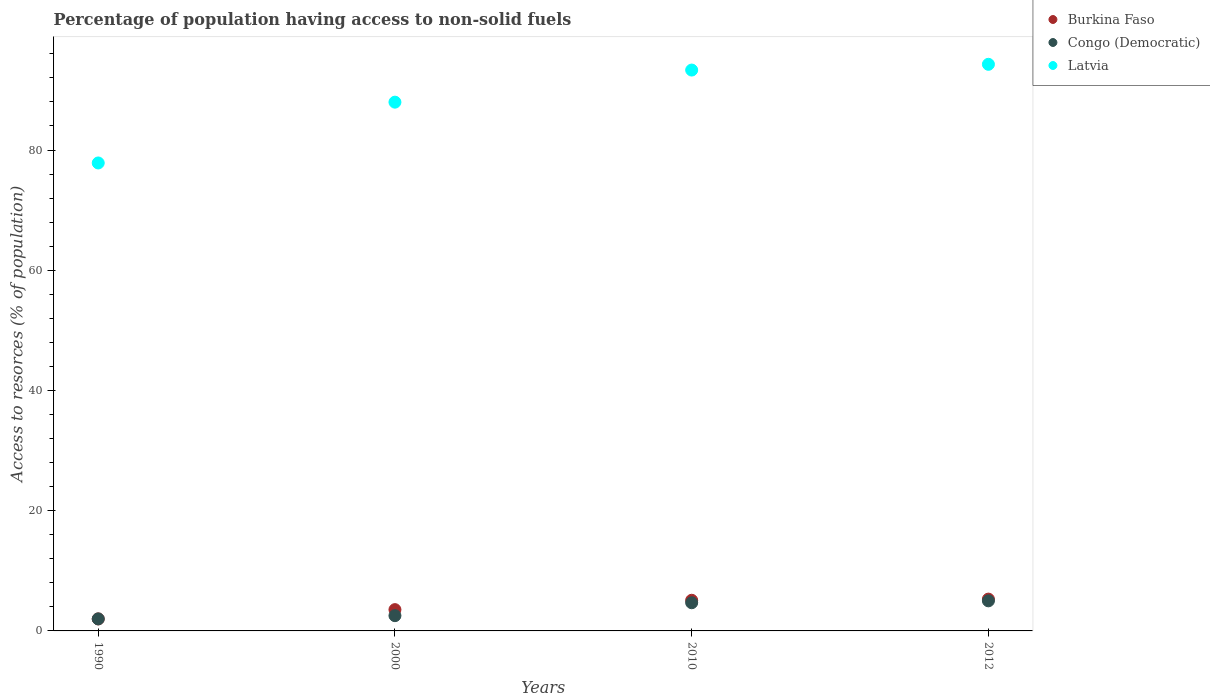How many different coloured dotlines are there?
Give a very brief answer. 3. Is the number of dotlines equal to the number of legend labels?
Offer a very short reply. Yes. What is the percentage of population having access to non-solid fuels in Latvia in 2012?
Keep it short and to the point. 94.26. Across all years, what is the maximum percentage of population having access to non-solid fuels in Burkina Faso?
Provide a succinct answer. 5.29. Across all years, what is the minimum percentage of population having access to non-solid fuels in Latvia?
Provide a short and direct response. 77.85. In which year was the percentage of population having access to non-solid fuels in Burkina Faso maximum?
Offer a terse response. 2012. What is the total percentage of population having access to non-solid fuels in Burkina Faso in the graph?
Offer a very short reply. 15.93. What is the difference between the percentage of population having access to non-solid fuels in Congo (Democratic) in 1990 and that in 2000?
Make the answer very short. -0.54. What is the difference between the percentage of population having access to non-solid fuels in Latvia in 1990 and the percentage of population having access to non-solid fuels in Congo (Democratic) in 2012?
Offer a very short reply. 72.85. What is the average percentage of population having access to non-solid fuels in Burkina Faso per year?
Ensure brevity in your answer.  3.98. In the year 2012, what is the difference between the percentage of population having access to non-solid fuels in Congo (Democratic) and percentage of population having access to non-solid fuels in Burkina Faso?
Your response must be concise. -0.29. In how many years, is the percentage of population having access to non-solid fuels in Latvia greater than 84 %?
Ensure brevity in your answer.  3. What is the ratio of the percentage of population having access to non-solid fuels in Congo (Democratic) in 1990 to that in 2012?
Provide a short and direct response. 0.4. Is the percentage of population having access to non-solid fuels in Burkina Faso in 1990 less than that in 2000?
Give a very brief answer. Yes. Is the difference between the percentage of population having access to non-solid fuels in Congo (Democratic) in 1990 and 2010 greater than the difference between the percentage of population having access to non-solid fuels in Burkina Faso in 1990 and 2010?
Make the answer very short. Yes. What is the difference between the highest and the second highest percentage of population having access to non-solid fuels in Latvia?
Give a very brief answer. 0.96. What is the difference between the highest and the lowest percentage of population having access to non-solid fuels in Latvia?
Give a very brief answer. 16.41. In how many years, is the percentage of population having access to non-solid fuels in Congo (Democratic) greater than the average percentage of population having access to non-solid fuels in Congo (Democratic) taken over all years?
Your response must be concise. 2. Is the sum of the percentage of population having access to non-solid fuels in Congo (Democratic) in 2000 and 2010 greater than the maximum percentage of population having access to non-solid fuels in Burkina Faso across all years?
Ensure brevity in your answer.  Yes. Is the percentage of population having access to non-solid fuels in Congo (Democratic) strictly greater than the percentage of population having access to non-solid fuels in Latvia over the years?
Give a very brief answer. No. Is the percentage of population having access to non-solid fuels in Congo (Democratic) strictly less than the percentage of population having access to non-solid fuels in Burkina Faso over the years?
Make the answer very short. No. How many dotlines are there?
Offer a terse response. 3. How many years are there in the graph?
Ensure brevity in your answer.  4. What is the difference between two consecutive major ticks on the Y-axis?
Make the answer very short. 20. Does the graph contain any zero values?
Provide a short and direct response. No. Does the graph contain grids?
Provide a short and direct response. No. Where does the legend appear in the graph?
Keep it short and to the point. Top right. What is the title of the graph?
Provide a succinct answer. Percentage of population having access to non-solid fuels. What is the label or title of the X-axis?
Offer a very short reply. Years. What is the label or title of the Y-axis?
Your answer should be compact. Access to resorces (% of population). What is the Access to resorces (% of population) in Burkina Faso in 1990?
Provide a succinct answer. 2. What is the Access to resorces (% of population) in Congo (Democratic) in 1990?
Your response must be concise. 2. What is the Access to resorces (% of population) of Latvia in 1990?
Keep it short and to the point. 77.85. What is the Access to resorces (% of population) of Burkina Faso in 2000?
Provide a succinct answer. 3.54. What is the Access to resorces (% of population) of Congo (Democratic) in 2000?
Your answer should be very brief. 2.54. What is the Access to resorces (% of population) in Latvia in 2000?
Your answer should be very brief. 87.97. What is the Access to resorces (% of population) of Burkina Faso in 2010?
Offer a very short reply. 5.1. What is the Access to resorces (% of population) in Congo (Democratic) in 2010?
Your answer should be very brief. 4.69. What is the Access to resorces (% of population) of Latvia in 2010?
Offer a very short reply. 93.31. What is the Access to resorces (% of population) of Burkina Faso in 2012?
Ensure brevity in your answer.  5.29. What is the Access to resorces (% of population) in Congo (Democratic) in 2012?
Your response must be concise. 5. What is the Access to resorces (% of population) in Latvia in 2012?
Your answer should be very brief. 94.26. Across all years, what is the maximum Access to resorces (% of population) in Burkina Faso?
Your answer should be compact. 5.29. Across all years, what is the maximum Access to resorces (% of population) in Congo (Democratic)?
Keep it short and to the point. 5. Across all years, what is the maximum Access to resorces (% of population) of Latvia?
Your answer should be very brief. 94.26. Across all years, what is the minimum Access to resorces (% of population) in Burkina Faso?
Offer a terse response. 2. Across all years, what is the minimum Access to resorces (% of population) of Congo (Democratic)?
Give a very brief answer. 2. Across all years, what is the minimum Access to resorces (% of population) in Latvia?
Your answer should be very brief. 77.85. What is the total Access to resorces (% of population) of Burkina Faso in the graph?
Ensure brevity in your answer.  15.93. What is the total Access to resorces (% of population) in Congo (Democratic) in the graph?
Provide a short and direct response. 14.23. What is the total Access to resorces (% of population) in Latvia in the graph?
Your response must be concise. 353.38. What is the difference between the Access to resorces (% of population) in Burkina Faso in 1990 and that in 2000?
Provide a succinct answer. -1.54. What is the difference between the Access to resorces (% of population) of Congo (Democratic) in 1990 and that in 2000?
Offer a terse response. -0.54. What is the difference between the Access to resorces (% of population) in Latvia in 1990 and that in 2000?
Offer a terse response. -10.12. What is the difference between the Access to resorces (% of population) in Burkina Faso in 1990 and that in 2010?
Provide a short and direct response. -3.1. What is the difference between the Access to resorces (% of population) of Congo (Democratic) in 1990 and that in 2010?
Your answer should be compact. -2.69. What is the difference between the Access to resorces (% of population) in Latvia in 1990 and that in 2010?
Your answer should be very brief. -15.46. What is the difference between the Access to resorces (% of population) of Burkina Faso in 1990 and that in 2012?
Provide a succinct answer. -3.29. What is the difference between the Access to resorces (% of population) of Congo (Democratic) in 1990 and that in 2012?
Your response must be concise. -3. What is the difference between the Access to resorces (% of population) in Latvia in 1990 and that in 2012?
Keep it short and to the point. -16.41. What is the difference between the Access to resorces (% of population) in Burkina Faso in 2000 and that in 2010?
Your answer should be compact. -1.56. What is the difference between the Access to resorces (% of population) in Congo (Democratic) in 2000 and that in 2010?
Offer a terse response. -2.15. What is the difference between the Access to resorces (% of population) in Latvia in 2000 and that in 2010?
Ensure brevity in your answer.  -5.34. What is the difference between the Access to resorces (% of population) in Burkina Faso in 2000 and that in 2012?
Provide a succinct answer. -1.75. What is the difference between the Access to resorces (% of population) of Congo (Democratic) in 2000 and that in 2012?
Give a very brief answer. -2.47. What is the difference between the Access to resorces (% of population) in Latvia in 2000 and that in 2012?
Ensure brevity in your answer.  -6.3. What is the difference between the Access to resorces (% of population) in Burkina Faso in 2010 and that in 2012?
Provide a short and direct response. -0.19. What is the difference between the Access to resorces (% of population) of Congo (Democratic) in 2010 and that in 2012?
Give a very brief answer. -0.32. What is the difference between the Access to resorces (% of population) of Latvia in 2010 and that in 2012?
Your answer should be compact. -0.96. What is the difference between the Access to resorces (% of population) of Burkina Faso in 1990 and the Access to resorces (% of population) of Congo (Democratic) in 2000?
Provide a succinct answer. -0.54. What is the difference between the Access to resorces (% of population) of Burkina Faso in 1990 and the Access to resorces (% of population) of Latvia in 2000?
Make the answer very short. -85.97. What is the difference between the Access to resorces (% of population) in Congo (Democratic) in 1990 and the Access to resorces (% of population) in Latvia in 2000?
Make the answer very short. -85.97. What is the difference between the Access to resorces (% of population) in Burkina Faso in 1990 and the Access to resorces (% of population) in Congo (Democratic) in 2010?
Ensure brevity in your answer.  -2.69. What is the difference between the Access to resorces (% of population) in Burkina Faso in 1990 and the Access to resorces (% of population) in Latvia in 2010?
Provide a short and direct response. -91.31. What is the difference between the Access to resorces (% of population) of Congo (Democratic) in 1990 and the Access to resorces (% of population) of Latvia in 2010?
Your response must be concise. -91.31. What is the difference between the Access to resorces (% of population) of Burkina Faso in 1990 and the Access to resorces (% of population) of Congo (Democratic) in 2012?
Your answer should be compact. -3. What is the difference between the Access to resorces (% of population) in Burkina Faso in 1990 and the Access to resorces (% of population) in Latvia in 2012?
Offer a terse response. -92.26. What is the difference between the Access to resorces (% of population) of Congo (Democratic) in 1990 and the Access to resorces (% of population) of Latvia in 2012?
Your answer should be very brief. -92.26. What is the difference between the Access to resorces (% of population) in Burkina Faso in 2000 and the Access to resorces (% of population) in Congo (Democratic) in 2010?
Give a very brief answer. -1.15. What is the difference between the Access to resorces (% of population) of Burkina Faso in 2000 and the Access to resorces (% of population) of Latvia in 2010?
Provide a succinct answer. -89.76. What is the difference between the Access to resorces (% of population) in Congo (Democratic) in 2000 and the Access to resorces (% of population) in Latvia in 2010?
Give a very brief answer. -90.77. What is the difference between the Access to resorces (% of population) of Burkina Faso in 2000 and the Access to resorces (% of population) of Congo (Democratic) in 2012?
Your answer should be very brief. -1.46. What is the difference between the Access to resorces (% of population) of Burkina Faso in 2000 and the Access to resorces (% of population) of Latvia in 2012?
Keep it short and to the point. -90.72. What is the difference between the Access to resorces (% of population) in Congo (Democratic) in 2000 and the Access to resorces (% of population) in Latvia in 2012?
Keep it short and to the point. -91.72. What is the difference between the Access to resorces (% of population) in Burkina Faso in 2010 and the Access to resorces (% of population) in Congo (Democratic) in 2012?
Your answer should be compact. 0.1. What is the difference between the Access to resorces (% of population) in Burkina Faso in 2010 and the Access to resorces (% of population) in Latvia in 2012?
Your answer should be very brief. -89.16. What is the difference between the Access to resorces (% of population) in Congo (Democratic) in 2010 and the Access to resorces (% of population) in Latvia in 2012?
Make the answer very short. -89.58. What is the average Access to resorces (% of population) of Burkina Faso per year?
Your answer should be compact. 3.98. What is the average Access to resorces (% of population) in Congo (Democratic) per year?
Offer a very short reply. 3.56. What is the average Access to resorces (% of population) of Latvia per year?
Your answer should be compact. 88.35. In the year 1990, what is the difference between the Access to resorces (% of population) of Burkina Faso and Access to resorces (% of population) of Congo (Democratic)?
Your answer should be compact. 0. In the year 1990, what is the difference between the Access to resorces (% of population) of Burkina Faso and Access to resorces (% of population) of Latvia?
Your answer should be very brief. -75.85. In the year 1990, what is the difference between the Access to resorces (% of population) in Congo (Democratic) and Access to resorces (% of population) in Latvia?
Your answer should be compact. -75.85. In the year 2000, what is the difference between the Access to resorces (% of population) of Burkina Faso and Access to resorces (% of population) of Congo (Democratic)?
Provide a succinct answer. 1. In the year 2000, what is the difference between the Access to resorces (% of population) in Burkina Faso and Access to resorces (% of population) in Latvia?
Your answer should be very brief. -84.42. In the year 2000, what is the difference between the Access to resorces (% of population) in Congo (Democratic) and Access to resorces (% of population) in Latvia?
Your response must be concise. -85.43. In the year 2010, what is the difference between the Access to resorces (% of population) of Burkina Faso and Access to resorces (% of population) of Congo (Democratic)?
Make the answer very short. 0.41. In the year 2010, what is the difference between the Access to resorces (% of population) of Burkina Faso and Access to resorces (% of population) of Latvia?
Keep it short and to the point. -88.21. In the year 2010, what is the difference between the Access to resorces (% of population) in Congo (Democratic) and Access to resorces (% of population) in Latvia?
Provide a short and direct response. -88.62. In the year 2012, what is the difference between the Access to resorces (% of population) of Burkina Faso and Access to resorces (% of population) of Congo (Democratic)?
Ensure brevity in your answer.  0.29. In the year 2012, what is the difference between the Access to resorces (% of population) of Burkina Faso and Access to resorces (% of population) of Latvia?
Make the answer very short. -88.97. In the year 2012, what is the difference between the Access to resorces (% of population) of Congo (Democratic) and Access to resorces (% of population) of Latvia?
Your response must be concise. -89.26. What is the ratio of the Access to resorces (% of population) in Burkina Faso in 1990 to that in 2000?
Provide a succinct answer. 0.56. What is the ratio of the Access to resorces (% of population) in Congo (Democratic) in 1990 to that in 2000?
Your answer should be compact. 0.79. What is the ratio of the Access to resorces (% of population) in Latvia in 1990 to that in 2000?
Provide a short and direct response. 0.89. What is the ratio of the Access to resorces (% of population) of Burkina Faso in 1990 to that in 2010?
Give a very brief answer. 0.39. What is the ratio of the Access to resorces (% of population) in Congo (Democratic) in 1990 to that in 2010?
Your answer should be very brief. 0.43. What is the ratio of the Access to resorces (% of population) in Latvia in 1990 to that in 2010?
Offer a very short reply. 0.83. What is the ratio of the Access to resorces (% of population) of Burkina Faso in 1990 to that in 2012?
Provide a short and direct response. 0.38. What is the ratio of the Access to resorces (% of population) in Congo (Democratic) in 1990 to that in 2012?
Provide a short and direct response. 0.4. What is the ratio of the Access to resorces (% of population) of Latvia in 1990 to that in 2012?
Make the answer very short. 0.83. What is the ratio of the Access to resorces (% of population) of Burkina Faso in 2000 to that in 2010?
Your answer should be very brief. 0.69. What is the ratio of the Access to resorces (% of population) of Congo (Democratic) in 2000 to that in 2010?
Offer a very short reply. 0.54. What is the ratio of the Access to resorces (% of population) in Latvia in 2000 to that in 2010?
Provide a short and direct response. 0.94. What is the ratio of the Access to resorces (% of population) in Burkina Faso in 2000 to that in 2012?
Offer a very short reply. 0.67. What is the ratio of the Access to resorces (% of population) in Congo (Democratic) in 2000 to that in 2012?
Offer a terse response. 0.51. What is the ratio of the Access to resorces (% of population) in Latvia in 2000 to that in 2012?
Make the answer very short. 0.93. What is the ratio of the Access to resorces (% of population) of Burkina Faso in 2010 to that in 2012?
Give a very brief answer. 0.96. What is the ratio of the Access to resorces (% of population) in Congo (Democratic) in 2010 to that in 2012?
Ensure brevity in your answer.  0.94. What is the ratio of the Access to resorces (% of population) of Latvia in 2010 to that in 2012?
Your answer should be very brief. 0.99. What is the difference between the highest and the second highest Access to resorces (% of population) in Burkina Faso?
Provide a succinct answer. 0.19. What is the difference between the highest and the second highest Access to resorces (% of population) of Congo (Democratic)?
Provide a succinct answer. 0.32. What is the difference between the highest and the second highest Access to resorces (% of population) of Latvia?
Offer a very short reply. 0.96. What is the difference between the highest and the lowest Access to resorces (% of population) of Burkina Faso?
Give a very brief answer. 3.29. What is the difference between the highest and the lowest Access to resorces (% of population) of Congo (Democratic)?
Give a very brief answer. 3. What is the difference between the highest and the lowest Access to resorces (% of population) in Latvia?
Ensure brevity in your answer.  16.41. 